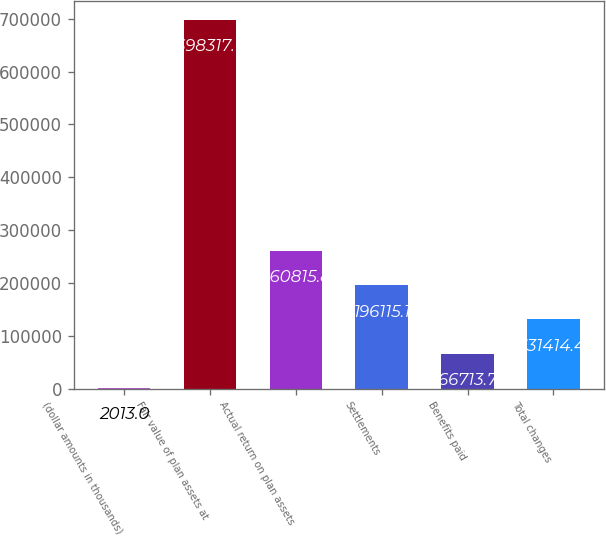Convert chart. <chart><loc_0><loc_0><loc_500><loc_500><bar_chart><fcel>(dollar amounts in thousands)<fcel>Fair value of plan assets at<fcel>Actual return on plan assets<fcel>Settlements<fcel>Benefits paid<fcel>Total changes<nl><fcel>2013<fcel>698318<fcel>260816<fcel>196115<fcel>66713.7<fcel>131414<nl></chart> 